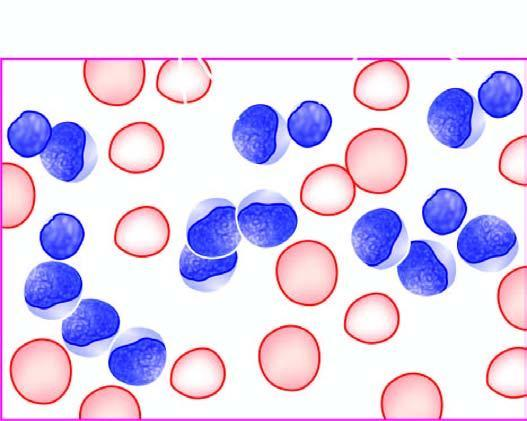what are large, with round to convoluted nuclei having high n/c ratio and no cytoplasmic granularity?
Answer the question using a single word or phrase. The cells 